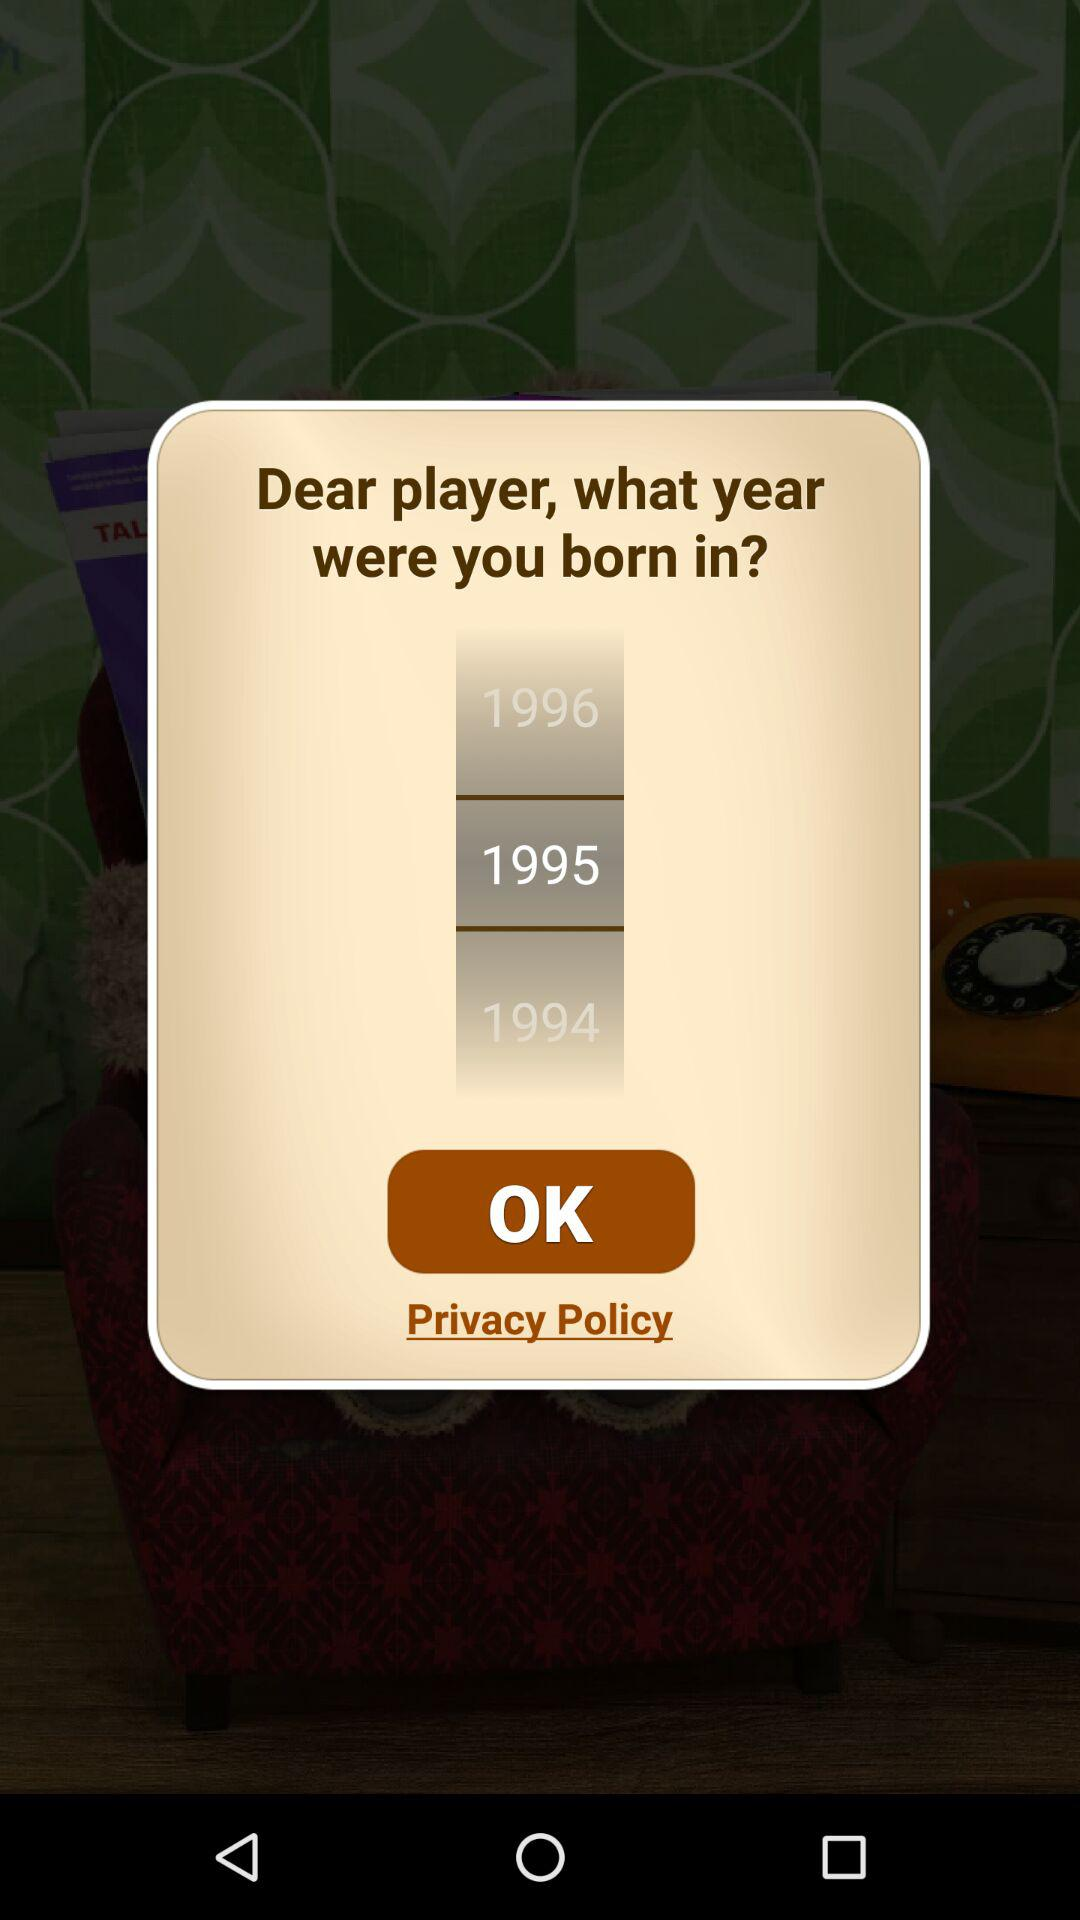How many years are between the oldest and youngest birth years?
Answer the question using a single word or phrase. 2 